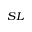Convert formula to latex. <formula><loc_0><loc_0><loc_500><loc_500>_ { S L }</formula> 